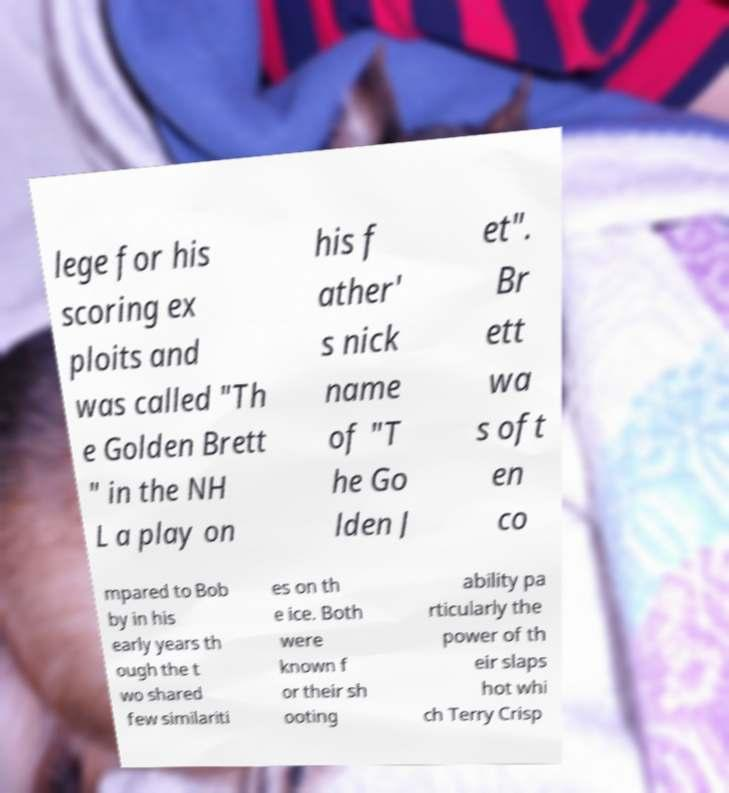Can you accurately transcribe the text from the provided image for me? lege for his scoring ex ploits and was called "Th e Golden Brett " in the NH L a play on his f ather' s nick name of "T he Go lden J et". Br ett wa s oft en co mpared to Bob by in his early years th ough the t wo shared few similariti es on th e ice. Both were known f or their sh ooting ability pa rticularly the power of th eir slaps hot whi ch Terry Crisp 